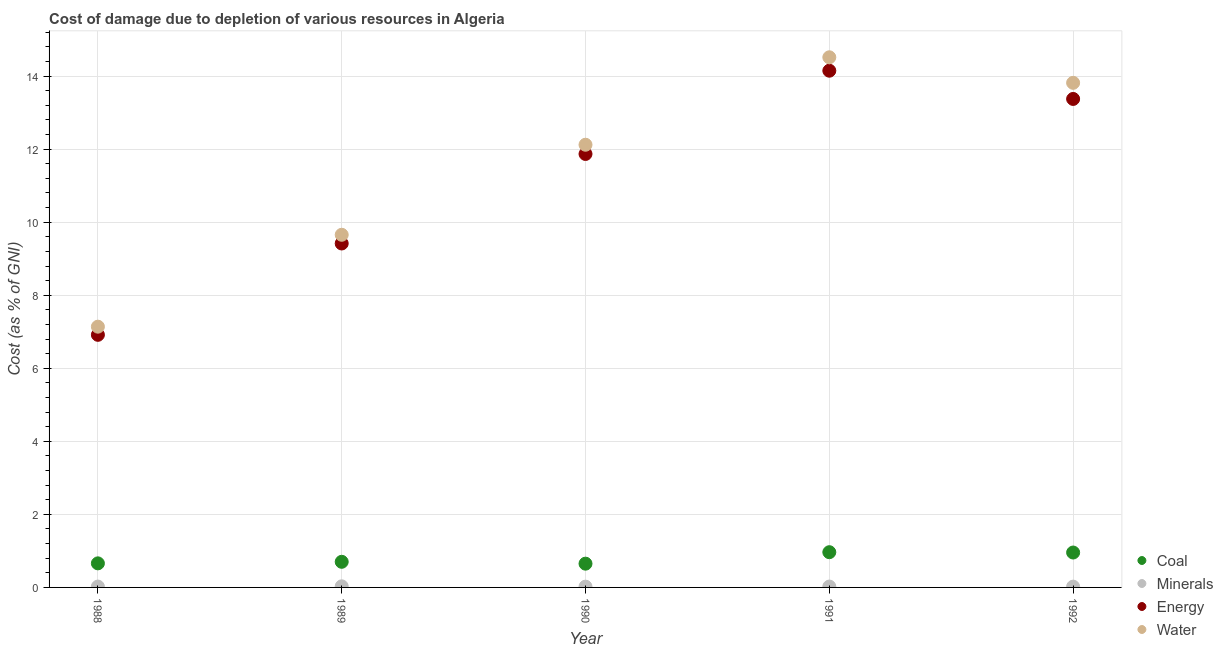How many different coloured dotlines are there?
Make the answer very short. 4. What is the cost of damage due to depletion of coal in 1991?
Offer a terse response. 0.96. Across all years, what is the maximum cost of damage due to depletion of coal?
Offer a terse response. 0.96. Across all years, what is the minimum cost of damage due to depletion of coal?
Make the answer very short. 0.65. What is the total cost of damage due to depletion of energy in the graph?
Ensure brevity in your answer.  55.72. What is the difference between the cost of damage due to depletion of minerals in 1988 and that in 1989?
Give a very brief answer. -0.01. What is the difference between the cost of damage due to depletion of minerals in 1990 and the cost of damage due to depletion of water in 1992?
Your response must be concise. -13.79. What is the average cost of damage due to depletion of energy per year?
Offer a terse response. 11.14. In the year 1992, what is the difference between the cost of damage due to depletion of coal and cost of damage due to depletion of water?
Your response must be concise. -12.86. What is the ratio of the cost of damage due to depletion of minerals in 1989 to that in 1992?
Your answer should be compact. 1.38. Is the cost of damage due to depletion of coal in 1991 less than that in 1992?
Your answer should be very brief. No. What is the difference between the highest and the second highest cost of damage due to depletion of coal?
Provide a succinct answer. 0.01. What is the difference between the highest and the lowest cost of damage due to depletion of minerals?
Offer a very short reply. 0.01. In how many years, is the cost of damage due to depletion of coal greater than the average cost of damage due to depletion of coal taken over all years?
Ensure brevity in your answer.  2. Is the sum of the cost of damage due to depletion of coal in 1990 and 1991 greater than the maximum cost of damage due to depletion of energy across all years?
Provide a short and direct response. No. Is it the case that in every year, the sum of the cost of damage due to depletion of energy and cost of damage due to depletion of water is greater than the sum of cost of damage due to depletion of coal and cost of damage due to depletion of minerals?
Provide a succinct answer. No. Is it the case that in every year, the sum of the cost of damage due to depletion of coal and cost of damage due to depletion of minerals is greater than the cost of damage due to depletion of energy?
Offer a very short reply. No. Is the cost of damage due to depletion of water strictly greater than the cost of damage due to depletion of coal over the years?
Provide a short and direct response. Yes. What is the difference between two consecutive major ticks on the Y-axis?
Offer a terse response. 2. Does the graph contain any zero values?
Your answer should be compact. No. Where does the legend appear in the graph?
Keep it short and to the point. Bottom right. How are the legend labels stacked?
Ensure brevity in your answer.  Vertical. What is the title of the graph?
Your answer should be very brief. Cost of damage due to depletion of various resources in Algeria . What is the label or title of the X-axis?
Your answer should be compact. Year. What is the label or title of the Y-axis?
Your response must be concise. Cost (as % of GNI). What is the Cost (as % of GNI) in Coal in 1988?
Make the answer very short. 0.66. What is the Cost (as % of GNI) in Minerals in 1988?
Keep it short and to the point. 0.02. What is the Cost (as % of GNI) of Energy in 1988?
Offer a very short reply. 6.92. What is the Cost (as % of GNI) in Water in 1988?
Ensure brevity in your answer.  7.14. What is the Cost (as % of GNI) in Coal in 1989?
Your response must be concise. 0.7. What is the Cost (as % of GNI) of Minerals in 1989?
Keep it short and to the point. 0.03. What is the Cost (as % of GNI) in Energy in 1989?
Your answer should be very brief. 9.42. What is the Cost (as % of GNI) in Water in 1989?
Provide a short and direct response. 9.66. What is the Cost (as % of GNI) of Coal in 1990?
Give a very brief answer. 0.65. What is the Cost (as % of GNI) of Minerals in 1990?
Give a very brief answer. 0.02. What is the Cost (as % of GNI) of Energy in 1990?
Keep it short and to the point. 11.87. What is the Cost (as % of GNI) in Water in 1990?
Give a very brief answer. 12.12. What is the Cost (as % of GNI) in Coal in 1991?
Ensure brevity in your answer.  0.96. What is the Cost (as % of GNI) of Minerals in 1991?
Make the answer very short. 0.02. What is the Cost (as % of GNI) in Energy in 1991?
Provide a short and direct response. 14.15. What is the Cost (as % of GNI) of Water in 1991?
Your answer should be compact. 14.51. What is the Cost (as % of GNI) of Coal in 1992?
Your answer should be very brief. 0.96. What is the Cost (as % of GNI) of Minerals in 1992?
Offer a very short reply. 0.02. What is the Cost (as % of GNI) of Energy in 1992?
Provide a short and direct response. 13.37. What is the Cost (as % of GNI) of Water in 1992?
Give a very brief answer. 13.82. Across all years, what is the maximum Cost (as % of GNI) in Coal?
Give a very brief answer. 0.96. Across all years, what is the maximum Cost (as % of GNI) in Minerals?
Provide a short and direct response. 0.03. Across all years, what is the maximum Cost (as % of GNI) of Energy?
Your answer should be compact. 14.15. Across all years, what is the maximum Cost (as % of GNI) of Water?
Offer a very short reply. 14.51. Across all years, what is the minimum Cost (as % of GNI) of Coal?
Your answer should be very brief. 0.65. Across all years, what is the minimum Cost (as % of GNI) of Minerals?
Your answer should be very brief. 0.02. Across all years, what is the minimum Cost (as % of GNI) of Energy?
Offer a terse response. 6.92. Across all years, what is the minimum Cost (as % of GNI) of Water?
Provide a short and direct response. 7.14. What is the total Cost (as % of GNI) in Coal in the graph?
Ensure brevity in your answer.  3.93. What is the total Cost (as % of GNI) in Minerals in the graph?
Provide a succinct answer. 0.12. What is the total Cost (as % of GNI) in Energy in the graph?
Provide a succinct answer. 55.72. What is the total Cost (as % of GNI) in Water in the graph?
Keep it short and to the point. 57.24. What is the difference between the Cost (as % of GNI) of Coal in 1988 and that in 1989?
Offer a terse response. -0.04. What is the difference between the Cost (as % of GNI) of Minerals in 1988 and that in 1989?
Offer a terse response. -0.01. What is the difference between the Cost (as % of GNI) in Energy in 1988 and that in 1989?
Give a very brief answer. -2.5. What is the difference between the Cost (as % of GNI) in Water in 1988 and that in 1989?
Keep it short and to the point. -2.52. What is the difference between the Cost (as % of GNI) in Coal in 1988 and that in 1990?
Offer a very short reply. 0.01. What is the difference between the Cost (as % of GNI) of Minerals in 1988 and that in 1990?
Provide a succinct answer. 0. What is the difference between the Cost (as % of GNI) in Energy in 1988 and that in 1990?
Your answer should be very brief. -4.95. What is the difference between the Cost (as % of GNI) of Water in 1988 and that in 1990?
Your response must be concise. -4.98. What is the difference between the Cost (as % of GNI) in Coal in 1988 and that in 1991?
Offer a terse response. -0.31. What is the difference between the Cost (as % of GNI) in Minerals in 1988 and that in 1991?
Provide a succinct answer. -0. What is the difference between the Cost (as % of GNI) in Energy in 1988 and that in 1991?
Ensure brevity in your answer.  -7.23. What is the difference between the Cost (as % of GNI) of Water in 1988 and that in 1991?
Your answer should be compact. -7.38. What is the difference between the Cost (as % of GNI) in Coal in 1988 and that in 1992?
Give a very brief answer. -0.3. What is the difference between the Cost (as % of GNI) in Minerals in 1988 and that in 1992?
Keep it short and to the point. 0. What is the difference between the Cost (as % of GNI) in Energy in 1988 and that in 1992?
Your answer should be compact. -6.46. What is the difference between the Cost (as % of GNI) of Water in 1988 and that in 1992?
Provide a succinct answer. -6.68. What is the difference between the Cost (as % of GNI) of Coal in 1989 and that in 1990?
Provide a short and direct response. 0.05. What is the difference between the Cost (as % of GNI) in Minerals in 1989 and that in 1990?
Keep it short and to the point. 0.01. What is the difference between the Cost (as % of GNI) in Energy in 1989 and that in 1990?
Ensure brevity in your answer.  -2.45. What is the difference between the Cost (as % of GNI) of Water in 1989 and that in 1990?
Offer a terse response. -2.47. What is the difference between the Cost (as % of GNI) in Coal in 1989 and that in 1991?
Provide a succinct answer. -0.26. What is the difference between the Cost (as % of GNI) in Minerals in 1989 and that in 1991?
Offer a terse response. 0.01. What is the difference between the Cost (as % of GNI) of Energy in 1989 and that in 1991?
Your response must be concise. -4.73. What is the difference between the Cost (as % of GNI) of Water in 1989 and that in 1991?
Your response must be concise. -4.86. What is the difference between the Cost (as % of GNI) in Coal in 1989 and that in 1992?
Offer a very short reply. -0.25. What is the difference between the Cost (as % of GNI) in Minerals in 1989 and that in 1992?
Your answer should be very brief. 0.01. What is the difference between the Cost (as % of GNI) of Energy in 1989 and that in 1992?
Your answer should be very brief. -3.96. What is the difference between the Cost (as % of GNI) of Water in 1989 and that in 1992?
Your response must be concise. -4.16. What is the difference between the Cost (as % of GNI) in Coal in 1990 and that in 1991?
Your answer should be very brief. -0.31. What is the difference between the Cost (as % of GNI) in Minerals in 1990 and that in 1991?
Provide a short and direct response. -0. What is the difference between the Cost (as % of GNI) in Energy in 1990 and that in 1991?
Provide a succinct answer. -2.28. What is the difference between the Cost (as % of GNI) in Water in 1990 and that in 1991?
Your answer should be compact. -2.39. What is the difference between the Cost (as % of GNI) of Coal in 1990 and that in 1992?
Provide a succinct answer. -0.3. What is the difference between the Cost (as % of GNI) of Minerals in 1990 and that in 1992?
Provide a succinct answer. -0. What is the difference between the Cost (as % of GNI) of Energy in 1990 and that in 1992?
Give a very brief answer. -1.51. What is the difference between the Cost (as % of GNI) of Water in 1990 and that in 1992?
Ensure brevity in your answer.  -1.69. What is the difference between the Cost (as % of GNI) in Coal in 1991 and that in 1992?
Ensure brevity in your answer.  0.01. What is the difference between the Cost (as % of GNI) in Minerals in 1991 and that in 1992?
Give a very brief answer. 0. What is the difference between the Cost (as % of GNI) of Energy in 1991 and that in 1992?
Keep it short and to the point. 0.77. What is the difference between the Cost (as % of GNI) of Water in 1991 and that in 1992?
Provide a short and direct response. 0.7. What is the difference between the Cost (as % of GNI) in Coal in 1988 and the Cost (as % of GNI) in Minerals in 1989?
Provide a short and direct response. 0.63. What is the difference between the Cost (as % of GNI) of Coal in 1988 and the Cost (as % of GNI) of Energy in 1989?
Ensure brevity in your answer.  -8.76. What is the difference between the Cost (as % of GNI) in Coal in 1988 and the Cost (as % of GNI) in Water in 1989?
Give a very brief answer. -9. What is the difference between the Cost (as % of GNI) in Minerals in 1988 and the Cost (as % of GNI) in Energy in 1989?
Provide a short and direct response. -9.39. What is the difference between the Cost (as % of GNI) of Minerals in 1988 and the Cost (as % of GNI) of Water in 1989?
Provide a succinct answer. -9.63. What is the difference between the Cost (as % of GNI) of Energy in 1988 and the Cost (as % of GNI) of Water in 1989?
Offer a very short reply. -2.74. What is the difference between the Cost (as % of GNI) in Coal in 1988 and the Cost (as % of GNI) in Minerals in 1990?
Ensure brevity in your answer.  0.64. What is the difference between the Cost (as % of GNI) in Coal in 1988 and the Cost (as % of GNI) in Energy in 1990?
Provide a short and direct response. -11.21. What is the difference between the Cost (as % of GNI) in Coal in 1988 and the Cost (as % of GNI) in Water in 1990?
Your response must be concise. -11.46. What is the difference between the Cost (as % of GNI) in Minerals in 1988 and the Cost (as % of GNI) in Energy in 1990?
Keep it short and to the point. -11.84. What is the difference between the Cost (as % of GNI) in Minerals in 1988 and the Cost (as % of GNI) in Water in 1990?
Provide a succinct answer. -12.1. What is the difference between the Cost (as % of GNI) in Energy in 1988 and the Cost (as % of GNI) in Water in 1990?
Provide a short and direct response. -5.2. What is the difference between the Cost (as % of GNI) in Coal in 1988 and the Cost (as % of GNI) in Minerals in 1991?
Keep it short and to the point. 0.64. What is the difference between the Cost (as % of GNI) of Coal in 1988 and the Cost (as % of GNI) of Energy in 1991?
Make the answer very short. -13.49. What is the difference between the Cost (as % of GNI) of Coal in 1988 and the Cost (as % of GNI) of Water in 1991?
Offer a very short reply. -13.86. What is the difference between the Cost (as % of GNI) in Minerals in 1988 and the Cost (as % of GNI) in Energy in 1991?
Make the answer very short. -14.12. What is the difference between the Cost (as % of GNI) of Minerals in 1988 and the Cost (as % of GNI) of Water in 1991?
Give a very brief answer. -14.49. What is the difference between the Cost (as % of GNI) of Energy in 1988 and the Cost (as % of GNI) of Water in 1991?
Keep it short and to the point. -7.6. What is the difference between the Cost (as % of GNI) of Coal in 1988 and the Cost (as % of GNI) of Minerals in 1992?
Ensure brevity in your answer.  0.64. What is the difference between the Cost (as % of GNI) in Coal in 1988 and the Cost (as % of GNI) in Energy in 1992?
Provide a succinct answer. -12.72. What is the difference between the Cost (as % of GNI) of Coal in 1988 and the Cost (as % of GNI) of Water in 1992?
Your answer should be compact. -13.16. What is the difference between the Cost (as % of GNI) of Minerals in 1988 and the Cost (as % of GNI) of Energy in 1992?
Your answer should be compact. -13.35. What is the difference between the Cost (as % of GNI) in Minerals in 1988 and the Cost (as % of GNI) in Water in 1992?
Provide a short and direct response. -13.79. What is the difference between the Cost (as % of GNI) of Energy in 1988 and the Cost (as % of GNI) of Water in 1992?
Provide a short and direct response. -6.9. What is the difference between the Cost (as % of GNI) of Coal in 1989 and the Cost (as % of GNI) of Minerals in 1990?
Your answer should be very brief. 0.68. What is the difference between the Cost (as % of GNI) of Coal in 1989 and the Cost (as % of GNI) of Energy in 1990?
Give a very brief answer. -11.17. What is the difference between the Cost (as % of GNI) of Coal in 1989 and the Cost (as % of GNI) of Water in 1990?
Offer a terse response. -11.42. What is the difference between the Cost (as % of GNI) in Minerals in 1989 and the Cost (as % of GNI) in Energy in 1990?
Give a very brief answer. -11.84. What is the difference between the Cost (as % of GNI) in Minerals in 1989 and the Cost (as % of GNI) in Water in 1990?
Provide a succinct answer. -12.09. What is the difference between the Cost (as % of GNI) of Energy in 1989 and the Cost (as % of GNI) of Water in 1990?
Provide a succinct answer. -2.7. What is the difference between the Cost (as % of GNI) of Coal in 1989 and the Cost (as % of GNI) of Minerals in 1991?
Offer a terse response. 0.68. What is the difference between the Cost (as % of GNI) of Coal in 1989 and the Cost (as % of GNI) of Energy in 1991?
Ensure brevity in your answer.  -13.45. What is the difference between the Cost (as % of GNI) in Coal in 1989 and the Cost (as % of GNI) in Water in 1991?
Keep it short and to the point. -13.81. What is the difference between the Cost (as % of GNI) in Minerals in 1989 and the Cost (as % of GNI) in Energy in 1991?
Provide a short and direct response. -14.12. What is the difference between the Cost (as % of GNI) in Minerals in 1989 and the Cost (as % of GNI) in Water in 1991?
Ensure brevity in your answer.  -14.48. What is the difference between the Cost (as % of GNI) of Energy in 1989 and the Cost (as % of GNI) of Water in 1991?
Keep it short and to the point. -5.1. What is the difference between the Cost (as % of GNI) of Coal in 1989 and the Cost (as % of GNI) of Minerals in 1992?
Keep it short and to the point. 0.68. What is the difference between the Cost (as % of GNI) of Coal in 1989 and the Cost (as % of GNI) of Energy in 1992?
Keep it short and to the point. -12.67. What is the difference between the Cost (as % of GNI) in Coal in 1989 and the Cost (as % of GNI) in Water in 1992?
Your answer should be very brief. -13.11. What is the difference between the Cost (as % of GNI) in Minerals in 1989 and the Cost (as % of GNI) in Energy in 1992?
Ensure brevity in your answer.  -13.34. What is the difference between the Cost (as % of GNI) in Minerals in 1989 and the Cost (as % of GNI) in Water in 1992?
Offer a terse response. -13.79. What is the difference between the Cost (as % of GNI) in Energy in 1989 and the Cost (as % of GNI) in Water in 1992?
Ensure brevity in your answer.  -4.4. What is the difference between the Cost (as % of GNI) of Coal in 1990 and the Cost (as % of GNI) of Minerals in 1991?
Your answer should be compact. 0.63. What is the difference between the Cost (as % of GNI) in Coal in 1990 and the Cost (as % of GNI) in Energy in 1991?
Provide a succinct answer. -13.5. What is the difference between the Cost (as % of GNI) in Coal in 1990 and the Cost (as % of GNI) in Water in 1991?
Ensure brevity in your answer.  -13.86. What is the difference between the Cost (as % of GNI) in Minerals in 1990 and the Cost (as % of GNI) in Energy in 1991?
Offer a very short reply. -14.13. What is the difference between the Cost (as % of GNI) of Minerals in 1990 and the Cost (as % of GNI) of Water in 1991?
Provide a short and direct response. -14.49. What is the difference between the Cost (as % of GNI) in Energy in 1990 and the Cost (as % of GNI) in Water in 1991?
Your response must be concise. -2.65. What is the difference between the Cost (as % of GNI) in Coal in 1990 and the Cost (as % of GNI) in Minerals in 1992?
Your response must be concise. 0.63. What is the difference between the Cost (as % of GNI) in Coal in 1990 and the Cost (as % of GNI) in Energy in 1992?
Provide a succinct answer. -12.72. What is the difference between the Cost (as % of GNI) of Coal in 1990 and the Cost (as % of GNI) of Water in 1992?
Your answer should be compact. -13.16. What is the difference between the Cost (as % of GNI) in Minerals in 1990 and the Cost (as % of GNI) in Energy in 1992?
Provide a short and direct response. -13.35. What is the difference between the Cost (as % of GNI) of Minerals in 1990 and the Cost (as % of GNI) of Water in 1992?
Ensure brevity in your answer.  -13.79. What is the difference between the Cost (as % of GNI) in Energy in 1990 and the Cost (as % of GNI) in Water in 1992?
Offer a very short reply. -1.95. What is the difference between the Cost (as % of GNI) of Coal in 1991 and the Cost (as % of GNI) of Minerals in 1992?
Your response must be concise. 0.94. What is the difference between the Cost (as % of GNI) of Coal in 1991 and the Cost (as % of GNI) of Energy in 1992?
Offer a terse response. -12.41. What is the difference between the Cost (as % of GNI) in Coal in 1991 and the Cost (as % of GNI) in Water in 1992?
Offer a very short reply. -12.85. What is the difference between the Cost (as % of GNI) in Minerals in 1991 and the Cost (as % of GNI) in Energy in 1992?
Offer a very short reply. -13.35. What is the difference between the Cost (as % of GNI) of Minerals in 1991 and the Cost (as % of GNI) of Water in 1992?
Offer a very short reply. -13.79. What is the difference between the Cost (as % of GNI) of Energy in 1991 and the Cost (as % of GNI) of Water in 1992?
Ensure brevity in your answer.  0.33. What is the average Cost (as % of GNI) of Coal per year?
Give a very brief answer. 0.79. What is the average Cost (as % of GNI) of Minerals per year?
Ensure brevity in your answer.  0.02. What is the average Cost (as % of GNI) of Energy per year?
Your answer should be very brief. 11.14. What is the average Cost (as % of GNI) of Water per year?
Provide a short and direct response. 11.45. In the year 1988, what is the difference between the Cost (as % of GNI) of Coal and Cost (as % of GNI) of Minerals?
Offer a very short reply. 0.64. In the year 1988, what is the difference between the Cost (as % of GNI) of Coal and Cost (as % of GNI) of Energy?
Your answer should be compact. -6.26. In the year 1988, what is the difference between the Cost (as % of GNI) in Coal and Cost (as % of GNI) in Water?
Provide a succinct answer. -6.48. In the year 1988, what is the difference between the Cost (as % of GNI) of Minerals and Cost (as % of GNI) of Energy?
Keep it short and to the point. -6.89. In the year 1988, what is the difference between the Cost (as % of GNI) of Minerals and Cost (as % of GNI) of Water?
Provide a short and direct response. -7.12. In the year 1988, what is the difference between the Cost (as % of GNI) of Energy and Cost (as % of GNI) of Water?
Give a very brief answer. -0.22. In the year 1989, what is the difference between the Cost (as % of GNI) in Coal and Cost (as % of GNI) in Minerals?
Offer a terse response. 0.67. In the year 1989, what is the difference between the Cost (as % of GNI) in Coal and Cost (as % of GNI) in Energy?
Your answer should be compact. -8.72. In the year 1989, what is the difference between the Cost (as % of GNI) in Coal and Cost (as % of GNI) in Water?
Make the answer very short. -8.95. In the year 1989, what is the difference between the Cost (as % of GNI) in Minerals and Cost (as % of GNI) in Energy?
Keep it short and to the point. -9.39. In the year 1989, what is the difference between the Cost (as % of GNI) in Minerals and Cost (as % of GNI) in Water?
Keep it short and to the point. -9.62. In the year 1989, what is the difference between the Cost (as % of GNI) of Energy and Cost (as % of GNI) of Water?
Your answer should be very brief. -0.24. In the year 1990, what is the difference between the Cost (as % of GNI) of Coal and Cost (as % of GNI) of Minerals?
Your answer should be very brief. 0.63. In the year 1990, what is the difference between the Cost (as % of GNI) of Coal and Cost (as % of GNI) of Energy?
Make the answer very short. -11.22. In the year 1990, what is the difference between the Cost (as % of GNI) of Coal and Cost (as % of GNI) of Water?
Offer a very short reply. -11.47. In the year 1990, what is the difference between the Cost (as % of GNI) in Minerals and Cost (as % of GNI) in Energy?
Make the answer very short. -11.85. In the year 1990, what is the difference between the Cost (as % of GNI) in Minerals and Cost (as % of GNI) in Water?
Give a very brief answer. -12.1. In the year 1990, what is the difference between the Cost (as % of GNI) in Energy and Cost (as % of GNI) in Water?
Provide a short and direct response. -0.25. In the year 1991, what is the difference between the Cost (as % of GNI) of Coal and Cost (as % of GNI) of Minerals?
Make the answer very short. 0.94. In the year 1991, what is the difference between the Cost (as % of GNI) in Coal and Cost (as % of GNI) in Energy?
Make the answer very short. -13.18. In the year 1991, what is the difference between the Cost (as % of GNI) in Coal and Cost (as % of GNI) in Water?
Your answer should be compact. -13.55. In the year 1991, what is the difference between the Cost (as % of GNI) in Minerals and Cost (as % of GNI) in Energy?
Keep it short and to the point. -14.12. In the year 1991, what is the difference between the Cost (as % of GNI) of Minerals and Cost (as % of GNI) of Water?
Your response must be concise. -14.49. In the year 1991, what is the difference between the Cost (as % of GNI) in Energy and Cost (as % of GNI) in Water?
Your answer should be very brief. -0.37. In the year 1992, what is the difference between the Cost (as % of GNI) in Coal and Cost (as % of GNI) in Minerals?
Your response must be concise. 0.93. In the year 1992, what is the difference between the Cost (as % of GNI) in Coal and Cost (as % of GNI) in Energy?
Offer a terse response. -12.42. In the year 1992, what is the difference between the Cost (as % of GNI) of Coal and Cost (as % of GNI) of Water?
Offer a terse response. -12.86. In the year 1992, what is the difference between the Cost (as % of GNI) in Minerals and Cost (as % of GNI) in Energy?
Make the answer very short. -13.35. In the year 1992, what is the difference between the Cost (as % of GNI) of Minerals and Cost (as % of GNI) of Water?
Give a very brief answer. -13.79. In the year 1992, what is the difference between the Cost (as % of GNI) in Energy and Cost (as % of GNI) in Water?
Make the answer very short. -0.44. What is the ratio of the Cost (as % of GNI) in Coal in 1988 to that in 1989?
Your answer should be compact. 0.94. What is the ratio of the Cost (as % of GNI) of Minerals in 1988 to that in 1989?
Ensure brevity in your answer.  0.77. What is the ratio of the Cost (as % of GNI) in Energy in 1988 to that in 1989?
Your answer should be compact. 0.73. What is the ratio of the Cost (as % of GNI) of Water in 1988 to that in 1989?
Give a very brief answer. 0.74. What is the ratio of the Cost (as % of GNI) of Coal in 1988 to that in 1990?
Make the answer very short. 1.01. What is the ratio of the Cost (as % of GNI) of Minerals in 1988 to that in 1990?
Your answer should be very brief. 1.09. What is the ratio of the Cost (as % of GNI) in Energy in 1988 to that in 1990?
Keep it short and to the point. 0.58. What is the ratio of the Cost (as % of GNI) of Water in 1988 to that in 1990?
Keep it short and to the point. 0.59. What is the ratio of the Cost (as % of GNI) of Coal in 1988 to that in 1991?
Keep it short and to the point. 0.68. What is the ratio of the Cost (as % of GNI) in Minerals in 1988 to that in 1991?
Your answer should be compact. 0.99. What is the ratio of the Cost (as % of GNI) of Energy in 1988 to that in 1991?
Ensure brevity in your answer.  0.49. What is the ratio of the Cost (as % of GNI) of Water in 1988 to that in 1991?
Your answer should be very brief. 0.49. What is the ratio of the Cost (as % of GNI) in Coal in 1988 to that in 1992?
Provide a succinct answer. 0.69. What is the ratio of the Cost (as % of GNI) of Minerals in 1988 to that in 1992?
Your answer should be very brief. 1.07. What is the ratio of the Cost (as % of GNI) in Energy in 1988 to that in 1992?
Provide a short and direct response. 0.52. What is the ratio of the Cost (as % of GNI) of Water in 1988 to that in 1992?
Your answer should be compact. 0.52. What is the ratio of the Cost (as % of GNI) of Coal in 1989 to that in 1990?
Keep it short and to the point. 1.08. What is the ratio of the Cost (as % of GNI) of Minerals in 1989 to that in 1990?
Provide a succinct answer. 1.41. What is the ratio of the Cost (as % of GNI) of Energy in 1989 to that in 1990?
Your response must be concise. 0.79. What is the ratio of the Cost (as % of GNI) of Water in 1989 to that in 1990?
Ensure brevity in your answer.  0.8. What is the ratio of the Cost (as % of GNI) in Coal in 1989 to that in 1991?
Your answer should be compact. 0.73. What is the ratio of the Cost (as % of GNI) of Minerals in 1989 to that in 1991?
Keep it short and to the point. 1.27. What is the ratio of the Cost (as % of GNI) of Energy in 1989 to that in 1991?
Give a very brief answer. 0.67. What is the ratio of the Cost (as % of GNI) in Water in 1989 to that in 1991?
Provide a short and direct response. 0.67. What is the ratio of the Cost (as % of GNI) of Coal in 1989 to that in 1992?
Offer a very short reply. 0.73. What is the ratio of the Cost (as % of GNI) of Minerals in 1989 to that in 1992?
Provide a succinct answer. 1.38. What is the ratio of the Cost (as % of GNI) of Energy in 1989 to that in 1992?
Your answer should be compact. 0.7. What is the ratio of the Cost (as % of GNI) of Water in 1989 to that in 1992?
Provide a succinct answer. 0.7. What is the ratio of the Cost (as % of GNI) in Coal in 1990 to that in 1991?
Give a very brief answer. 0.67. What is the ratio of the Cost (as % of GNI) of Minerals in 1990 to that in 1991?
Keep it short and to the point. 0.91. What is the ratio of the Cost (as % of GNI) in Energy in 1990 to that in 1991?
Provide a succinct answer. 0.84. What is the ratio of the Cost (as % of GNI) of Water in 1990 to that in 1991?
Your answer should be compact. 0.83. What is the ratio of the Cost (as % of GNI) of Coal in 1990 to that in 1992?
Your answer should be very brief. 0.68. What is the ratio of the Cost (as % of GNI) of Minerals in 1990 to that in 1992?
Provide a short and direct response. 0.98. What is the ratio of the Cost (as % of GNI) in Energy in 1990 to that in 1992?
Offer a very short reply. 0.89. What is the ratio of the Cost (as % of GNI) in Water in 1990 to that in 1992?
Make the answer very short. 0.88. What is the ratio of the Cost (as % of GNI) in Coal in 1991 to that in 1992?
Offer a terse response. 1.01. What is the ratio of the Cost (as % of GNI) in Minerals in 1991 to that in 1992?
Offer a very short reply. 1.08. What is the ratio of the Cost (as % of GNI) in Energy in 1991 to that in 1992?
Your response must be concise. 1.06. What is the ratio of the Cost (as % of GNI) of Water in 1991 to that in 1992?
Ensure brevity in your answer.  1.05. What is the difference between the highest and the second highest Cost (as % of GNI) of Coal?
Ensure brevity in your answer.  0.01. What is the difference between the highest and the second highest Cost (as % of GNI) of Minerals?
Give a very brief answer. 0.01. What is the difference between the highest and the second highest Cost (as % of GNI) in Energy?
Keep it short and to the point. 0.77. What is the difference between the highest and the second highest Cost (as % of GNI) of Water?
Offer a terse response. 0.7. What is the difference between the highest and the lowest Cost (as % of GNI) of Coal?
Give a very brief answer. 0.31. What is the difference between the highest and the lowest Cost (as % of GNI) in Minerals?
Offer a very short reply. 0.01. What is the difference between the highest and the lowest Cost (as % of GNI) of Energy?
Keep it short and to the point. 7.23. What is the difference between the highest and the lowest Cost (as % of GNI) of Water?
Offer a terse response. 7.38. 